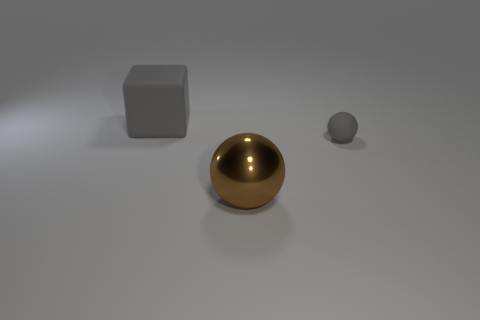Is there any other thing that is the same shape as the big gray rubber object?
Offer a very short reply. No. Are the big object that is on the left side of the big metallic thing and the tiny gray thing made of the same material?
Keep it short and to the point. Yes. What number of big cubes are the same material as the tiny gray object?
Your answer should be very brief. 1. Are there more things that are left of the brown object than big cyan matte things?
Your answer should be very brief. Yes. The other matte thing that is the same color as the small rubber thing is what size?
Give a very brief answer. Large. Is there another rubber thing that has the same shape as the brown object?
Provide a succinct answer. Yes. How many things are gray objects or tiny rubber things?
Your answer should be very brief. 2. There is a sphere to the right of the large brown metallic sphere that is in front of the gray matte cube; what number of large objects are to the left of it?
Make the answer very short. 2. There is another object that is the same shape as the big brown thing; what is its material?
Offer a terse response. Rubber. What material is the object that is to the left of the small sphere and in front of the gray cube?
Your answer should be compact. Metal. 